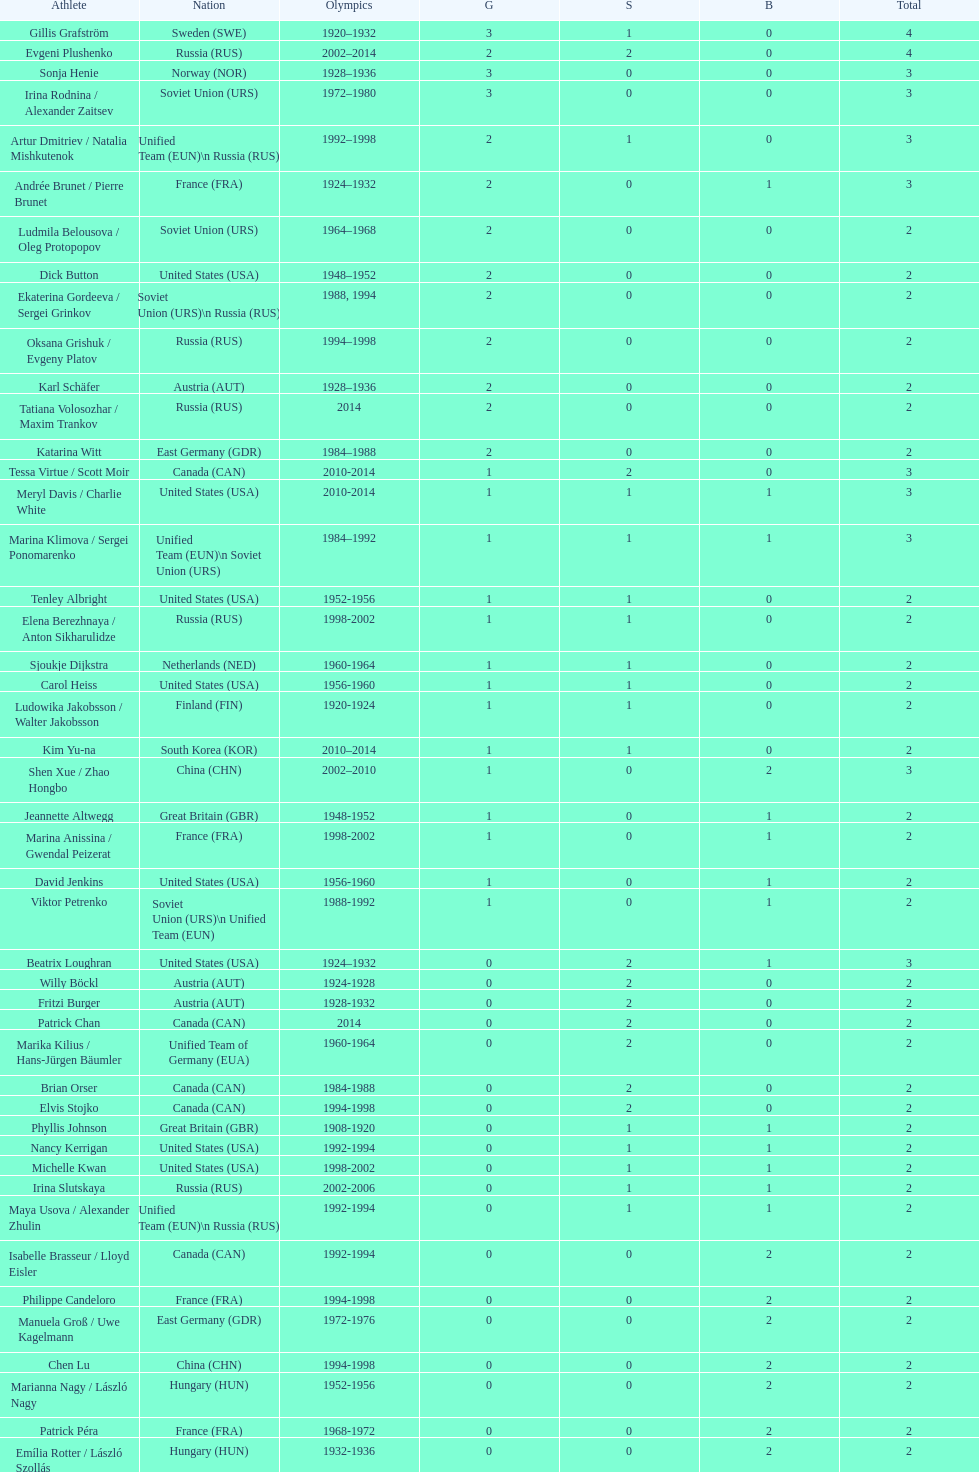Which nation was the first to win three gold medals for olympic figure skating? Sweden. 